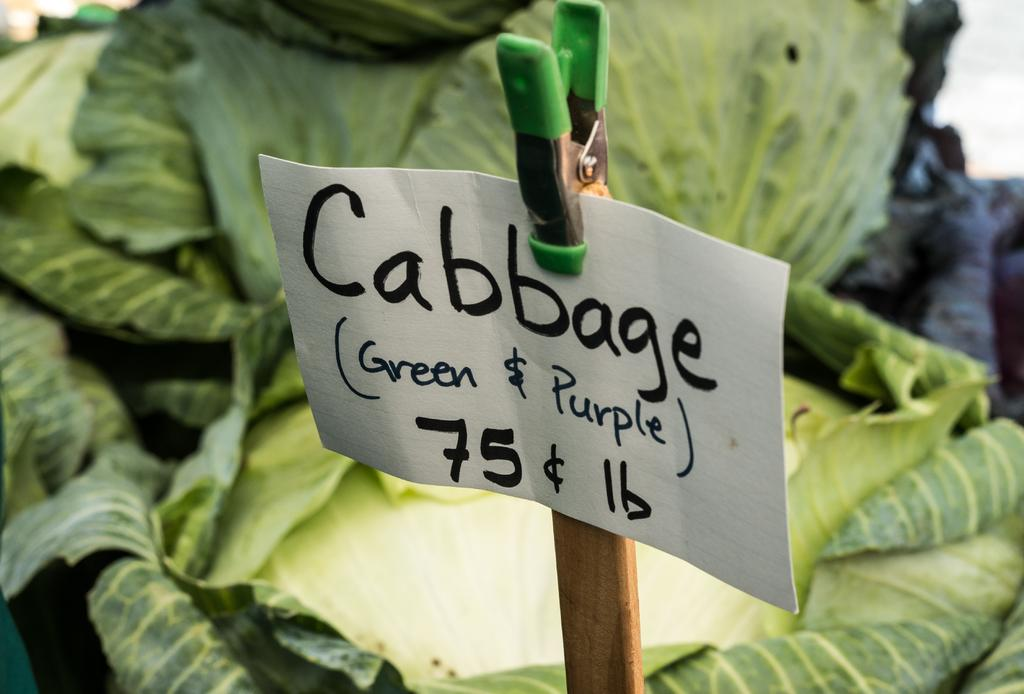What is attached to the pole in the image? There is a board attached to a pole in the image. What is written on the board? The name "cabbage" is written on the board. What type of objects can be seen in the image besides the board and pole? There are vegetables visible in the image. What is the color of the vegetables? The vegetables are green in color. Are there any bears visible in the image? No, there are no bears present in the image. What is the mouth of the cabbage doing in the image? There is no mouth associated with the cabbage or any other object in the image. 